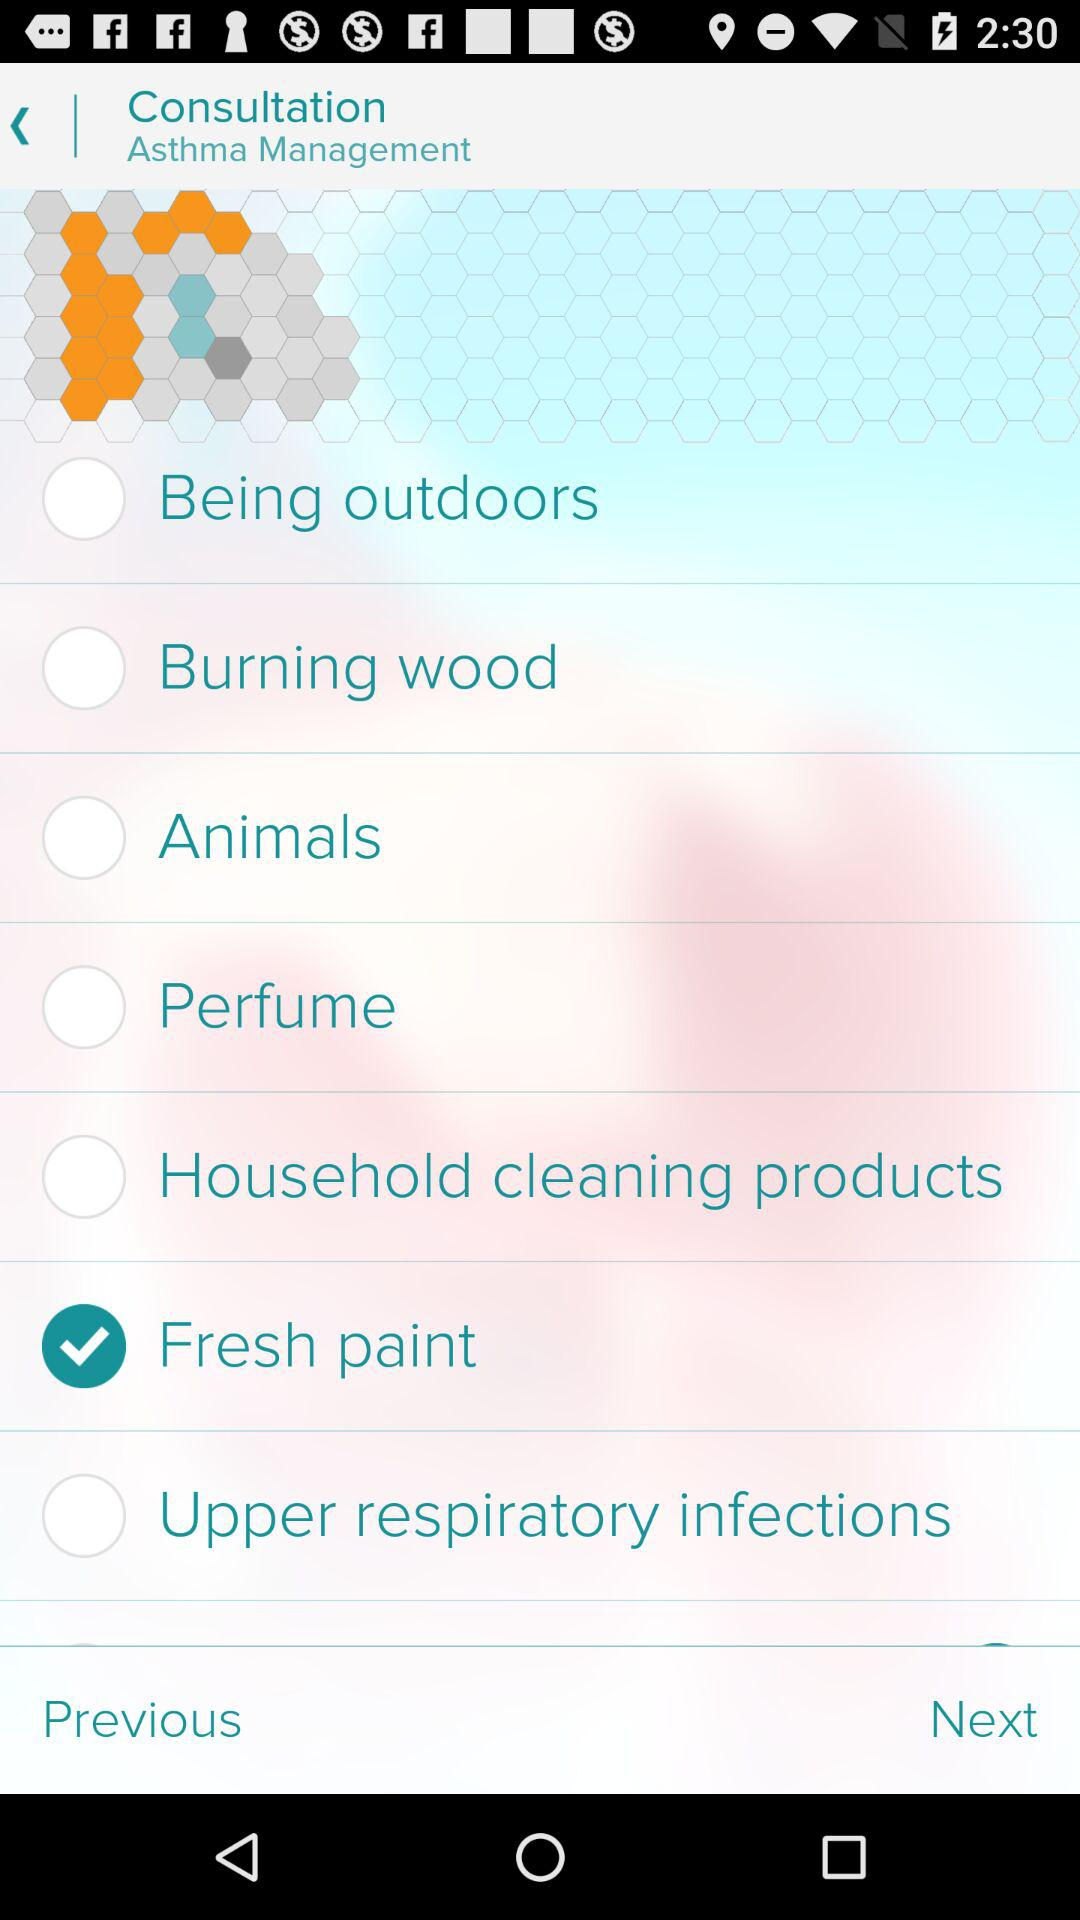What management is sponsoring the consultation application? The management that is sponsoring the consultation application is "Asthma". 